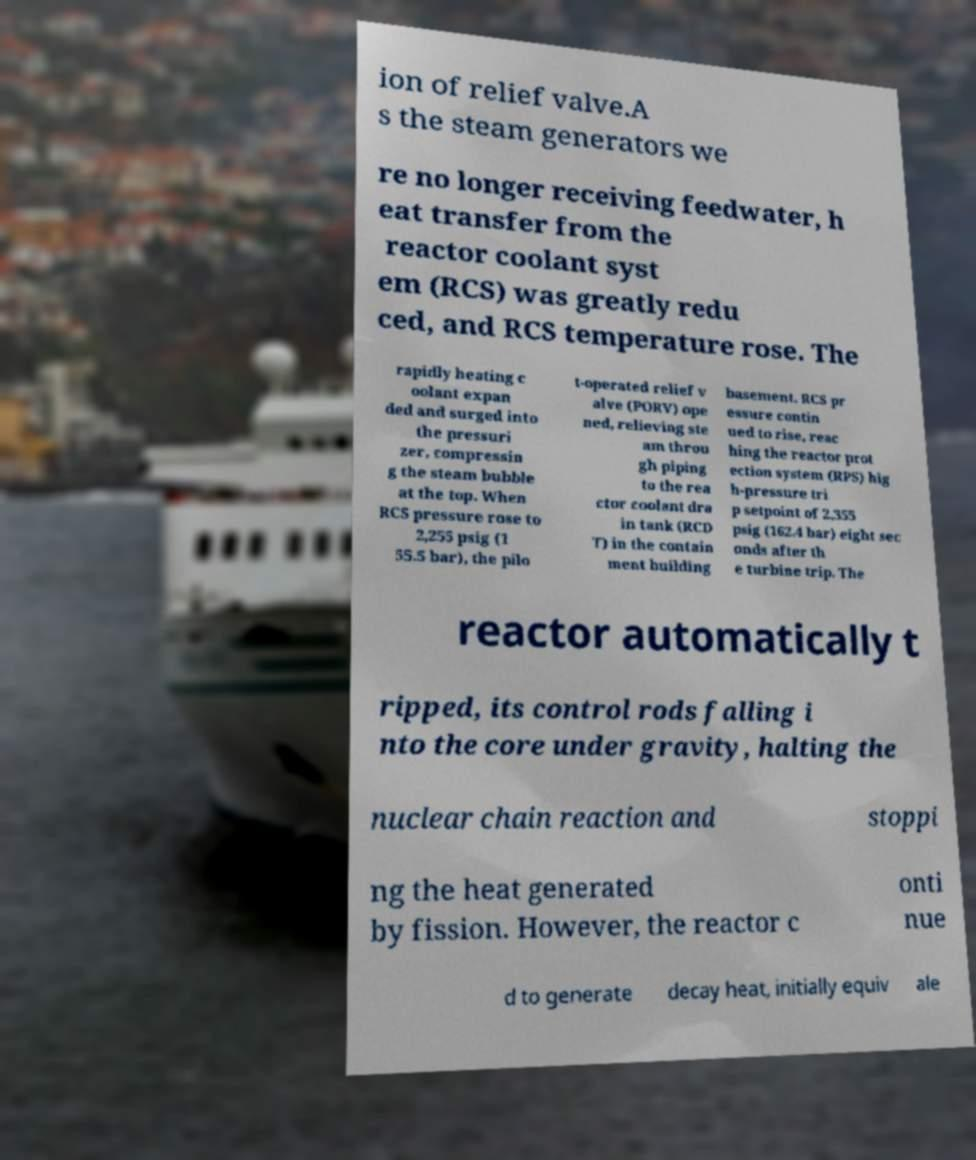For documentation purposes, I need the text within this image transcribed. Could you provide that? ion of relief valve.A s the steam generators we re no longer receiving feedwater, h eat transfer from the reactor coolant syst em (RCS) was greatly redu ced, and RCS temperature rose. The rapidly heating c oolant expan ded and surged into the pressuri zer, compressin g the steam bubble at the top. When RCS pressure rose to 2,255 psig (1 55.5 bar), the pilo t-operated relief v alve (PORV) ope ned, relieving ste am throu gh piping to the rea ctor coolant dra in tank (RCD T) in the contain ment building basement. RCS pr essure contin ued to rise, reac hing the reactor prot ection system (RPS) hig h-pressure tri p setpoint of 2,355 psig (162.4 bar) eight sec onds after th e turbine trip. The reactor automatically t ripped, its control rods falling i nto the core under gravity, halting the nuclear chain reaction and stoppi ng the heat generated by fission. However, the reactor c onti nue d to generate decay heat, initially equiv ale 